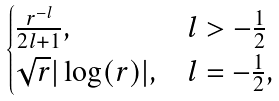<formula> <loc_0><loc_0><loc_500><loc_500>\begin{cases} \frac { r ^ { - l } } { 2 l + 1 } , & l > - \frac { 1 } { 2 } \\ \sqrt { r } | \log ( r ) | , & l = - \frac { 1 } { 2 } , \end{cases}</formula> 